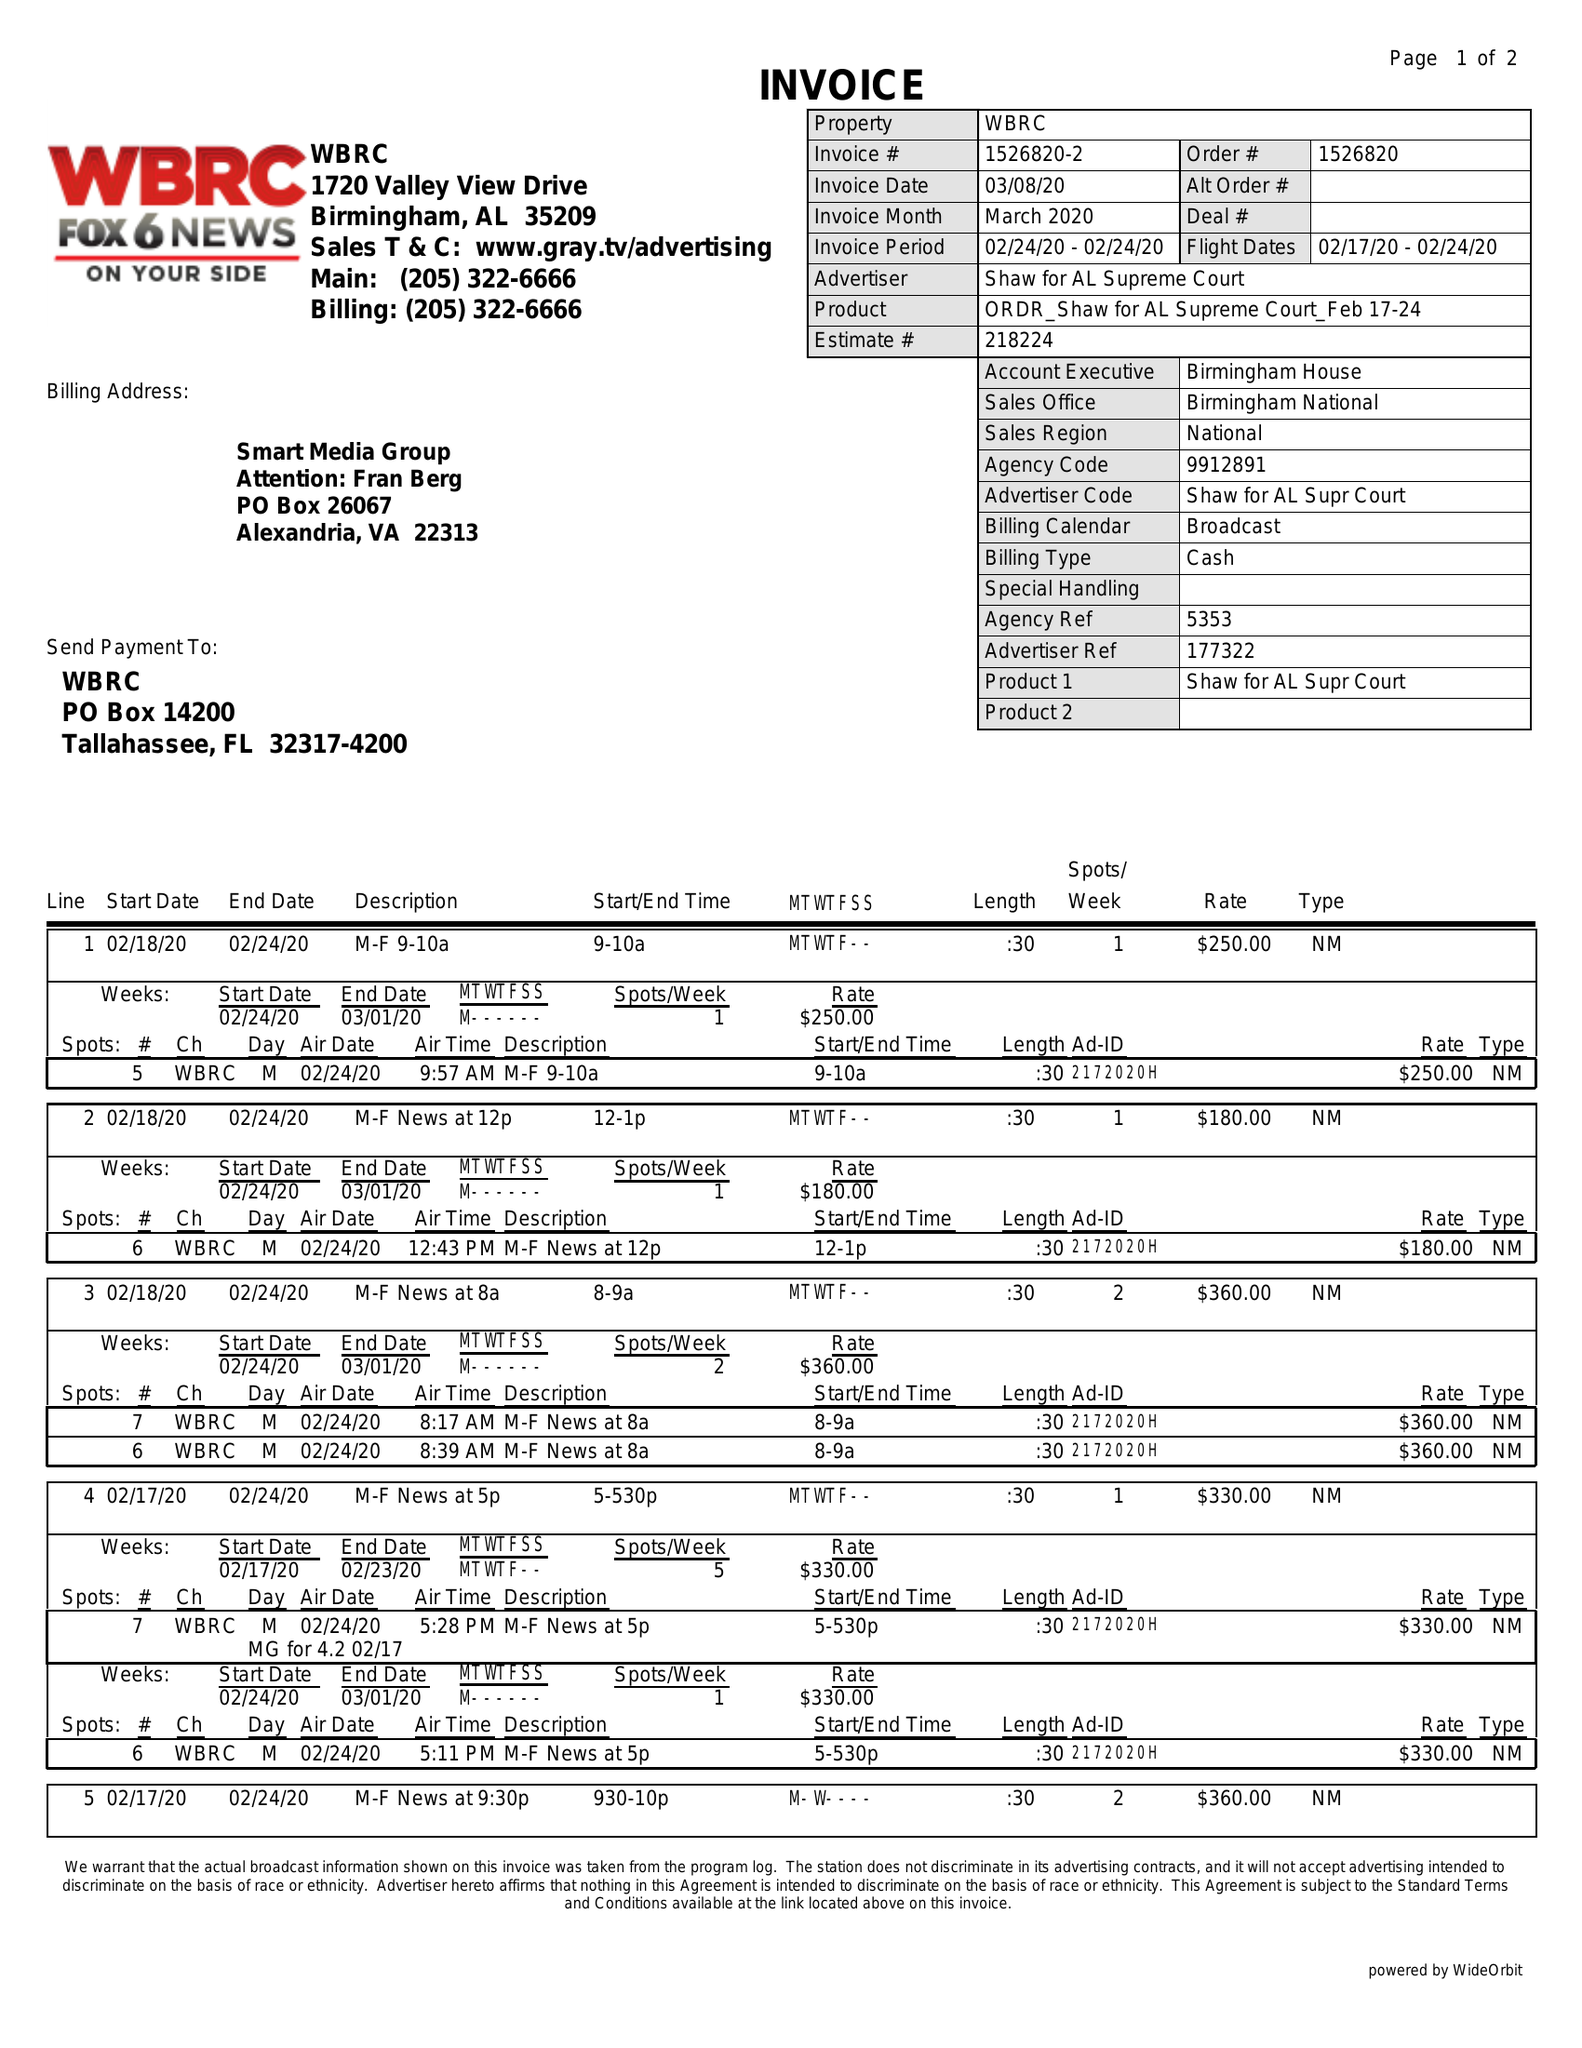What is the value for the flight_to?
Answer the question using a single word or phrase. 02/24/20 